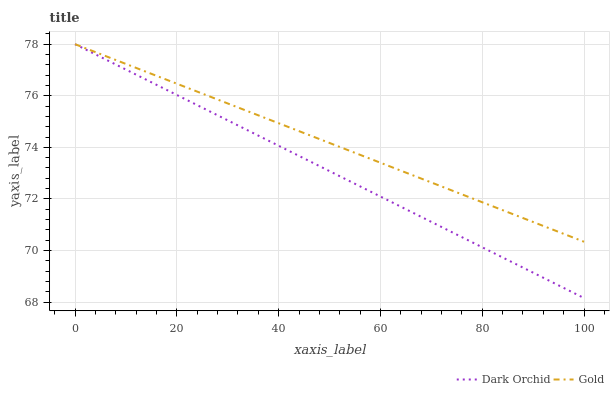Does Dark Orchid have the minimum area under the curve?
Answer yes or no. Yes. Does Gold have the maximum area under the curve?
Answer yes or no. Yes. Does Dark Orchid have the maximum area under the curve?
Answer yes or no. No. Is Dark Orchid the smoothest?
Answer yes or no. Yes. Is Gold the roughest?
Answer yes or no. Yes. Is Dark Orchid the roughest?
Answer yes or no. No. Does Dark Orchid have the lowest value?
Answer yes or no. Yes. Does Dark Orchid have the highest value?
Answer yes or no. Yes. Does Dark Orchid intersect Gold?
Answer yes or no. Yes. Is Dark Orchid less than Gold?
Answer yes or no. No. Is Dark Orchid greater than Gold?
Answer yes or no. No. 